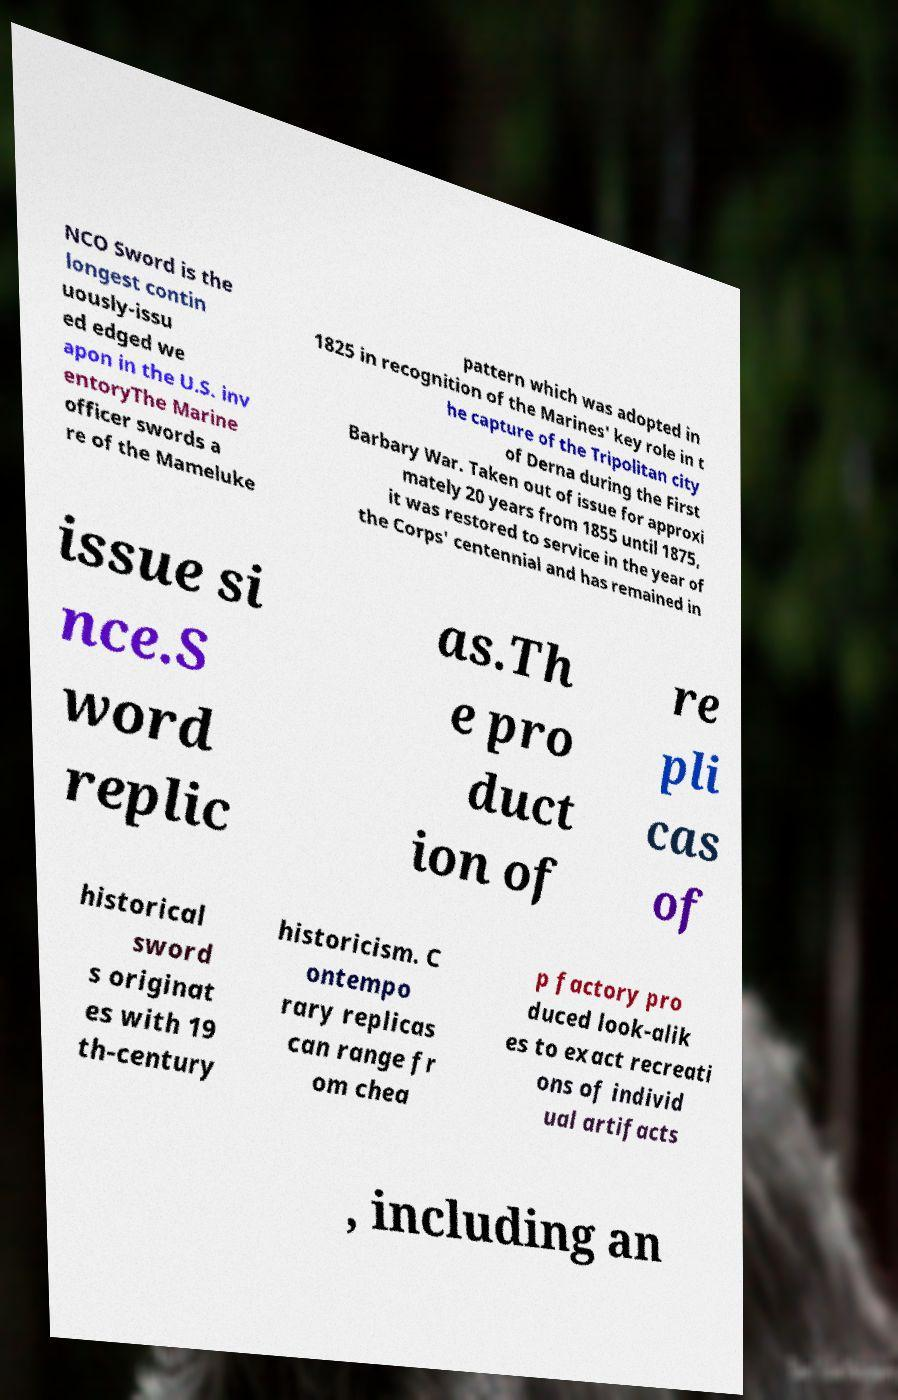I need the written content from this picture converted into text. Can you do that? NCO Sword is the longest contin uously-issu ed edged we apon in the U.S. inv entoryThe Marine officer swords a re of the Mameluke pattern which was adopted in 1825 in recognition of the Marines' key role in t he capture of the Tripolitan city of Derna during the First Barbary War. Taken out of issue for approxi mately 20 years from 1855 until 1875, it was restored to service in the year of the Corps' centennial and has remained in issue si nce.S word replic as.Th e pro duct ion of re pli cas of historical sword s originat es with 19 th-century historicism. C ontempo rary replicas can range fr om chea p factory pro duced look-alik es to exact recreati ons of individ ual artifacts , including an 